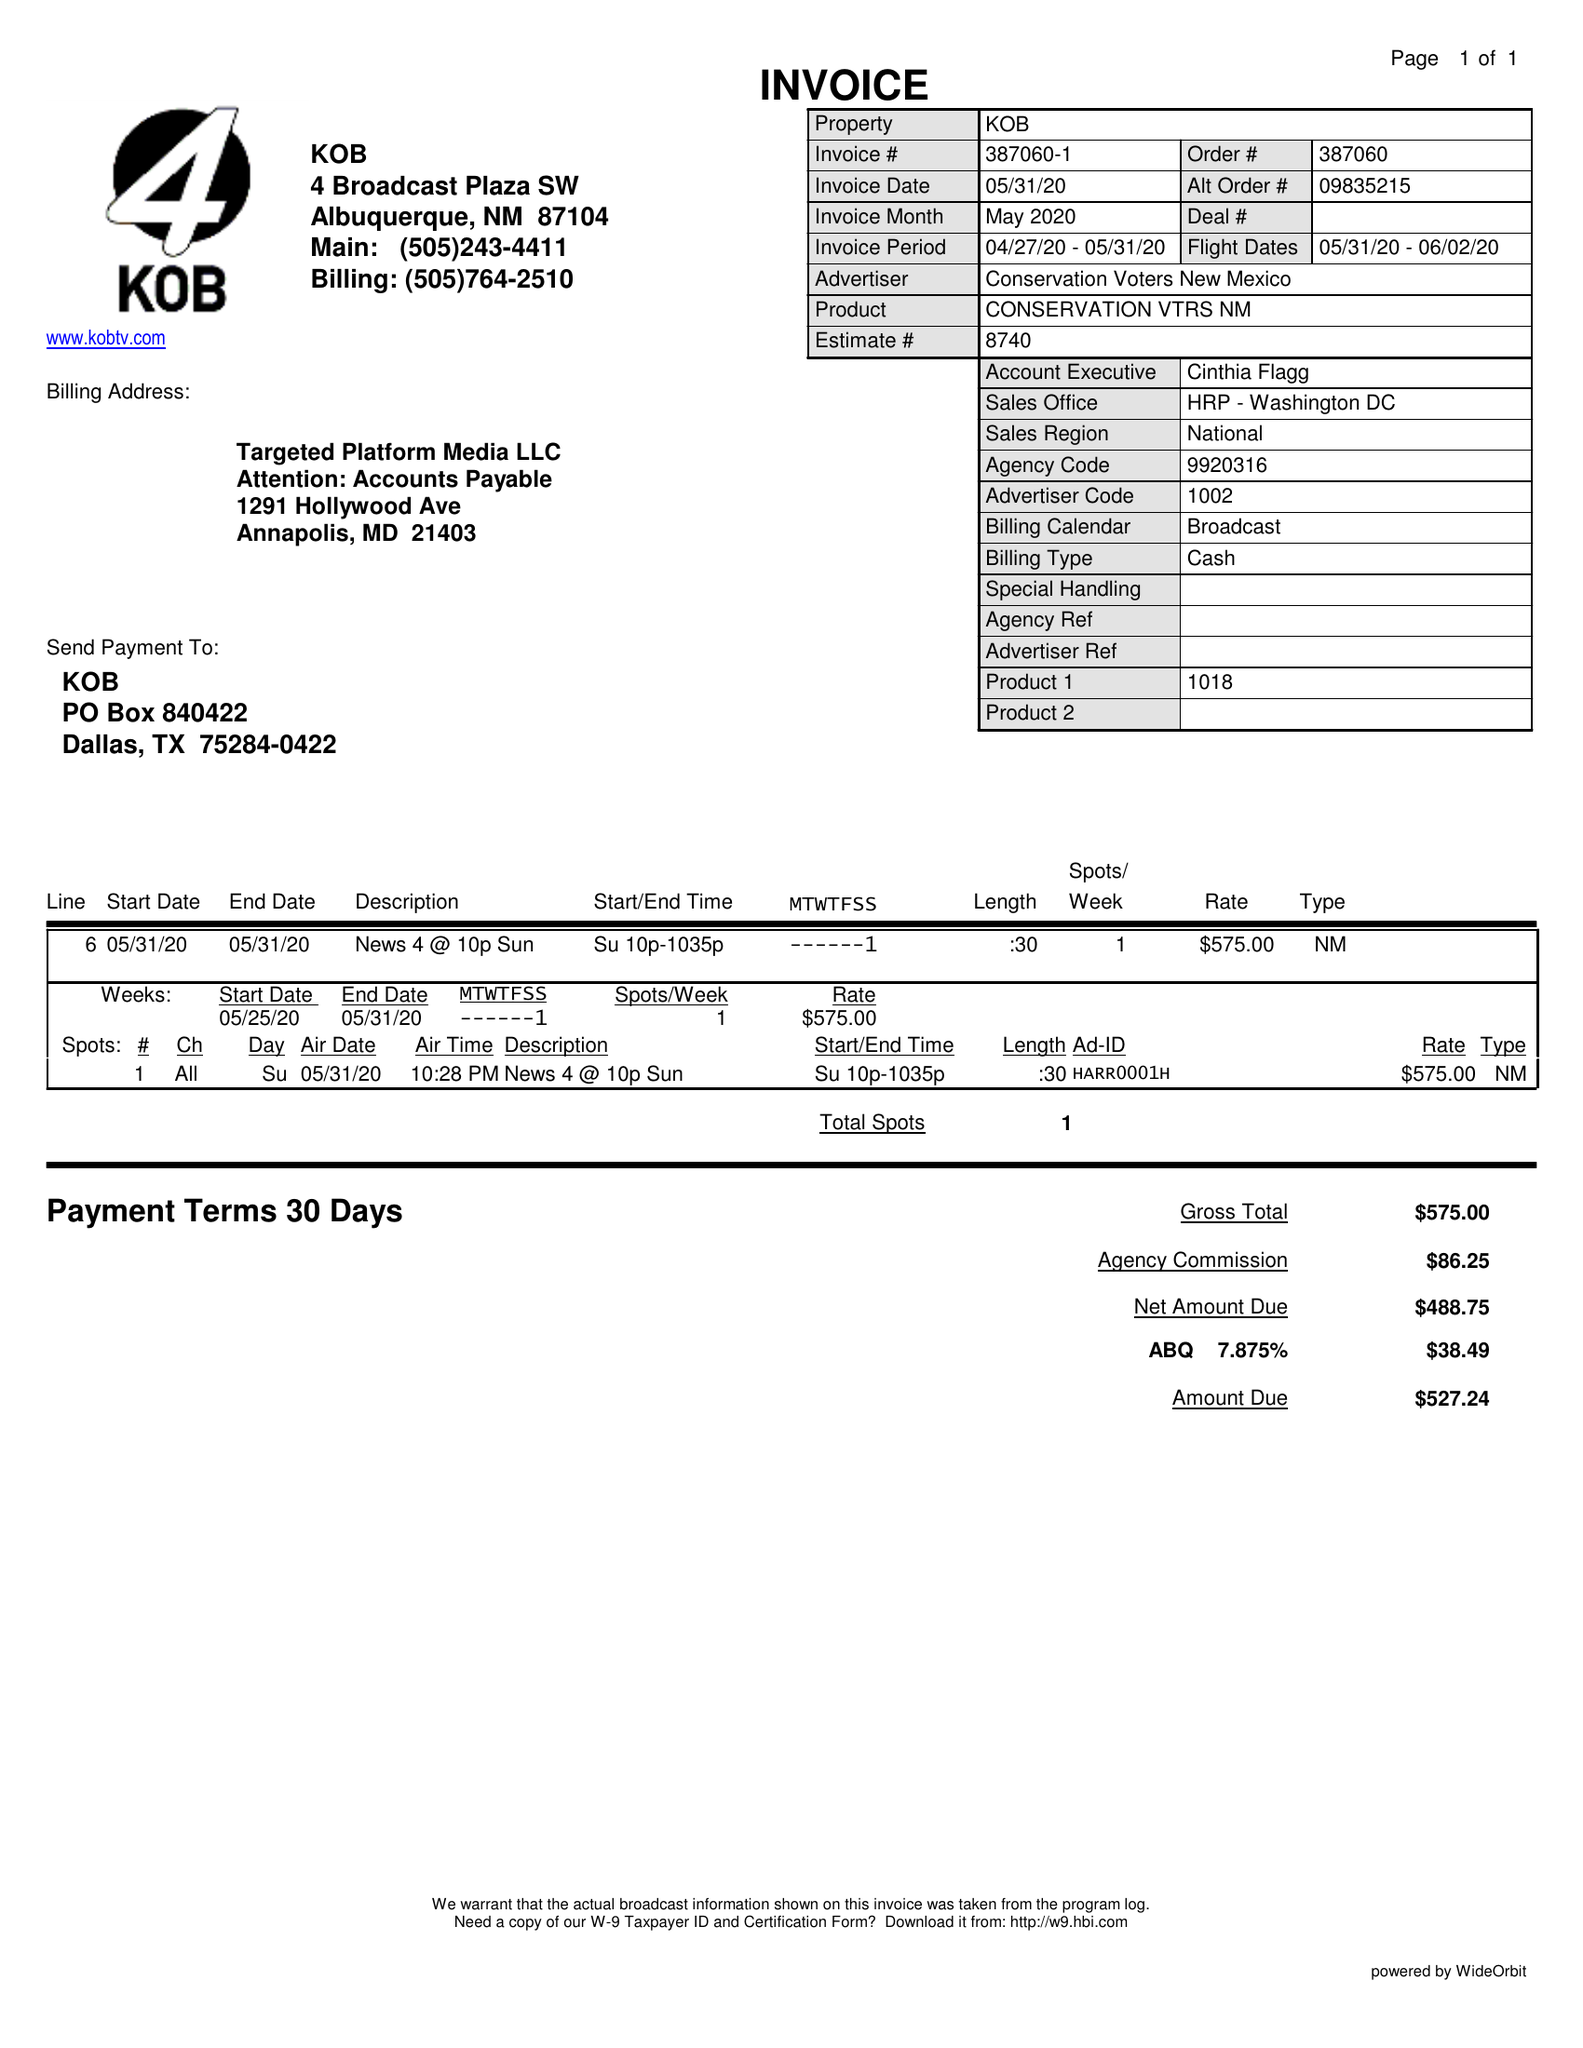What is the value for the gross_amount?
Answer the question using a single word or phrase. 575.00 